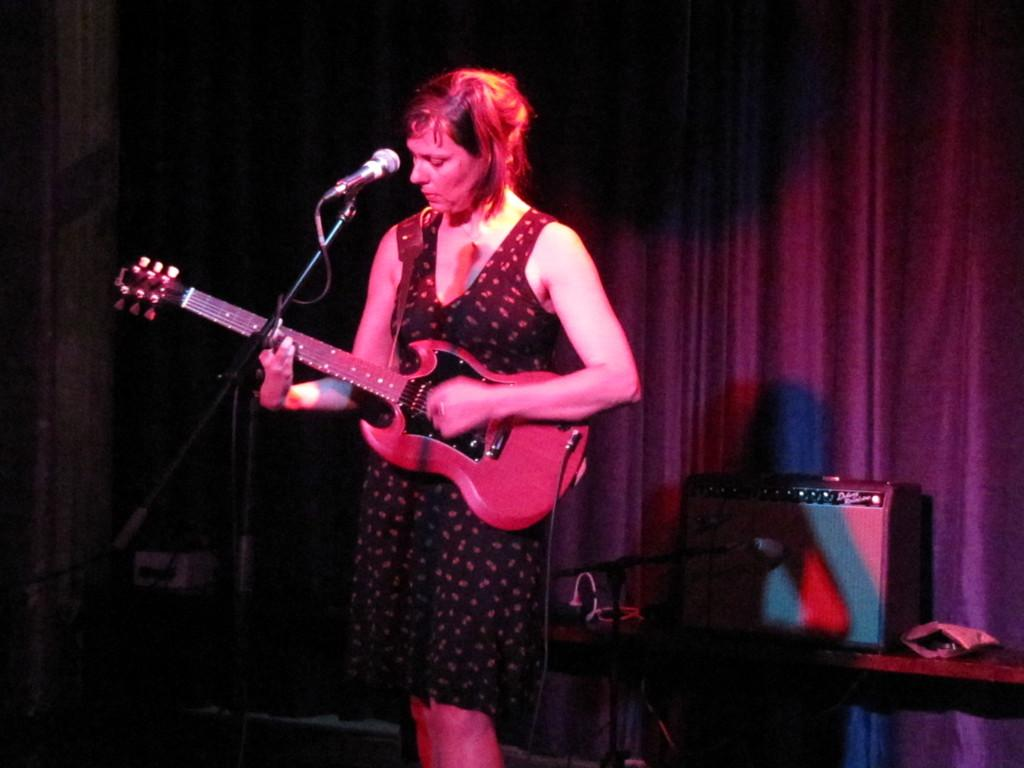Who is present in the image? There is a woman in the image. What is the woman doing in the image? The woman is standing and holding a guitar. What can be seen in the background of the image? There is a microphone, a curtain, and a table with boxes on it in the background. What type of bait is the woman using to catch fish in the image? There is no indication of fishing or bait in the image; the woman is holding a guitar and there is a microphone and curtain in the background. 